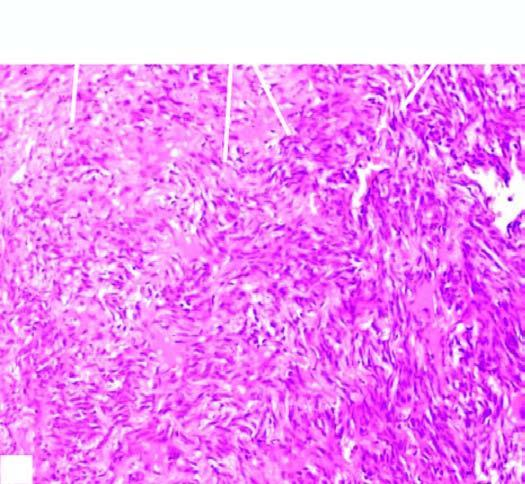how does sectioned surface of the lung show replacement of slaty-grey spongy parenchyma?
Answer the question using a single word or phrase. With multiple 